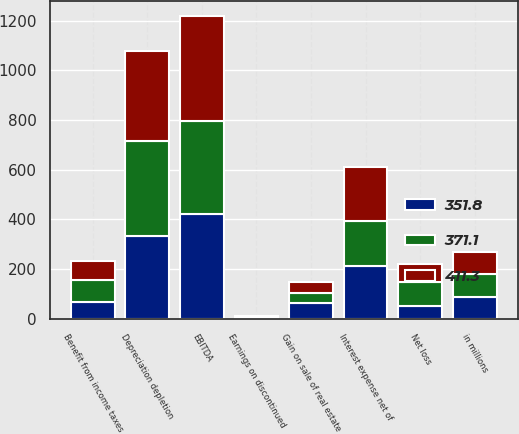Convert chart. <chart><loc_0><loc_0><loc_500><loc_500><stacked_bar_chart><ecel><fcel>in millions<fcel>Net loss<fcel>Benefit from income taxes<fcel>Interest expense net of<fcel>Earnings on discontinued<fcel>Depreciation depletion<fcel>EBITDA<fcel>Gain on sale of real estate<nl><fcel>351.8<fcel>89.7<fcel>52.6<fcel>66.5<fcel>211.9<fcel>1.3<fcel>332<fcel>423.5<fcel>65.1<nl><fcel>411.3<fcel>89.7<fcel>70.8<fcel>78.5<fcel>217.3<fcel>4.5<fcel>361.7<fcel>425.2<fcel>42.1<nl><fcel>371.1<fcel>89.7<fcel>96.5<fcel>89.7<fcel>180.7<fcel>6<fcel>382.1<fcel>370.6<fcel>39.5<nl></chart> 